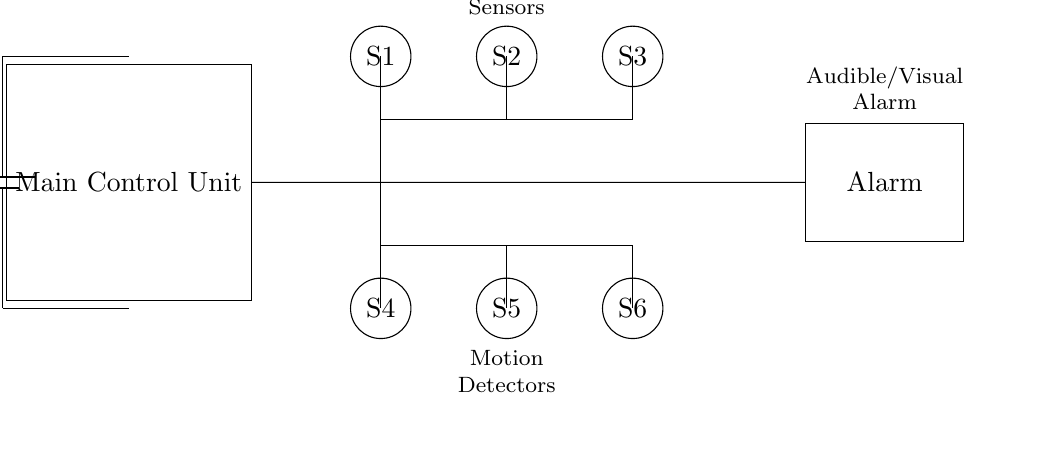What is the voltage of this circuit? The voltage is 12 volts, as indicated by the battery component at the top of the circuit diagram.
Answer: 12 volts What are the types of sensors used in this alarm system? The sensors are door/window sensors and motion detectors, as labeled in the circuit diagram.
Answer: Door/Window Sensors and Motion Detectors How many sensors are present in the circuit? There are six sensors in total, with three labeled at the top for door/window and three at the bottom for motion detection.
Answer: Six What is the function of the main control unit? The main control unit processes signals from the sensors and activates the alarm system when a breach is detected.
Answer: Control signals processing Where does the alarm connect in the circuit? The alarm connects to the right side of the main control unit, as shown by the line leading directly to it.
Answer: Right side of the main control unit What would happen if a door/window sensor is triggered? If a door/window sensor is triggered, it sends a signal to the main control unit, which will then activate the alarm.
Answer: Alarm activates Which component provides the power for the entire circuit? The battery component provides the power supply at the top left of the circuit.
Answer: Battery 